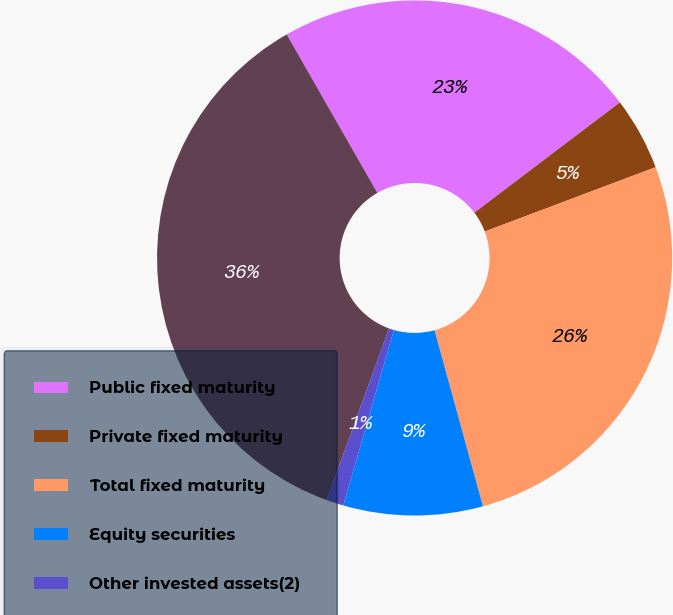Convert chart to OTSL. <chart><loc_0><loc_0><loc_500><loc_500><pie_chart><fcel>Public fixed maturity<fcel>Private fixed maturity<fcel>Total fixed maturity<fcel>Equity securities<fcel>Other invested assets(2)<fcel>Total<nl><fcel>22.95%<fcel>4.59%<fcel>26.46%<fcel>8.74%<fcel>1.08%<fcel>36.18%<nl></chart> 